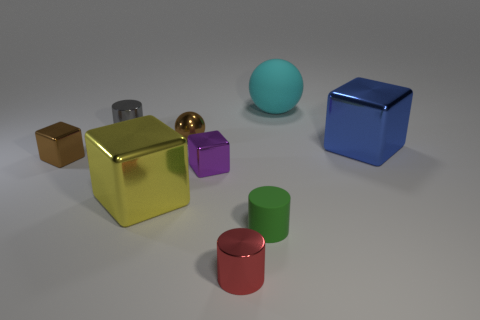Imagine these objects are part of a game. What could be the rules involving these shapes and colors? In such a game, these objects could be used for a matching challenge where players must combine similar shapes or colors. For example, pairing metallic with metallic, cubes with cubes, or matching colors within a time limit to score points. Reflective objects might grant bonus points, while pairing objects of different shapes or colors could result in penalties. 